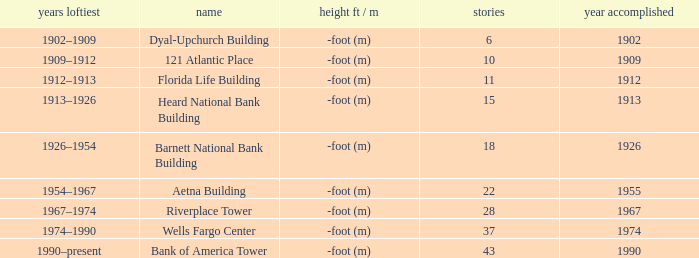How tall is the florida life building, completed before 1990? -foot (m). 